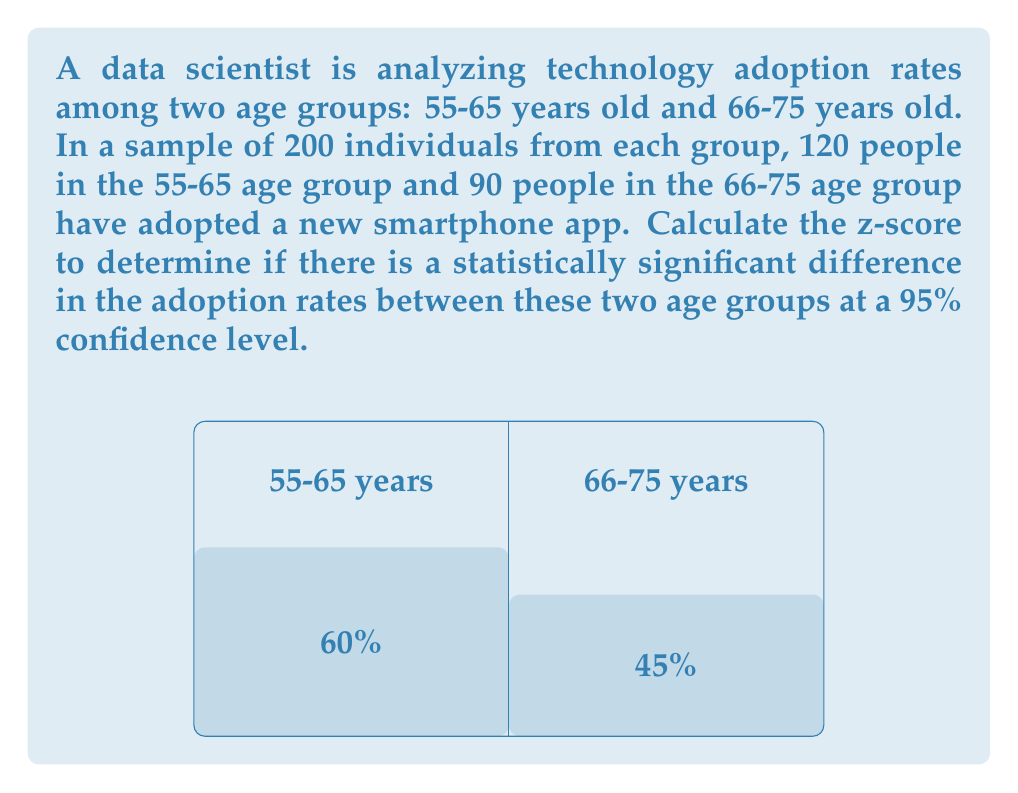Could you help me with this problem? To determine if there's a statistically significant difference in adoption rates, we'll use a two-proportion z-test. Let's follow these steps:

1) Define our hypotheses:
   $H_0: p_1 = p_2$ (null hypothesis: no difference in proportions)
   $H_a: p_1 \neq p_2$ (alternative hypothesis: there is a difference)

2) Calculate the sample proportions:
   $\hat{p}_1 = 120/200 = 0.60$ for the 55-65 age group
   $\hat{p}_2 = 90/200 = 0.45$ for the 66-75 age group

3) Calculate the pooled sample proportion:
   $$\hat{p} = \frac{x_1 + x_2}{n_1 + n_2} = \frac{120 + 90}{200 + 200} = \frac{210}{400} = 0.525$$

4) Calculate the standard error:
   $$SE = \sqrt{\hat{p}(1-\hat{p})(\frac{1}{n_1} + \frac{1}{n_2})}$$
   $$SE = \sqrt{0.525(1-0.525)(\frac{1}{200} + \frac{1}{200})} = 0.0498$$

5) Calculate the z-score:
   $$z = \frac{\hat{p}_1 - \hat{p}_2}{SE} = \frac{0.60 - 0.45}{0.0498} = 3.012$$

6) Determine the critical value:
   For a 95% confidence level (α = 0.05) and a two-tailed test, the critical z-value is ±1.96.

7) Compare the calculated z-score to the critical value:
   |3.012| > 1.96, so we reject the null hypothesis.

Therefore, there is a statistically significant difference in adoption rates between the two age groups at the 95% confidence level.
Answer: $z = 3.012$ 